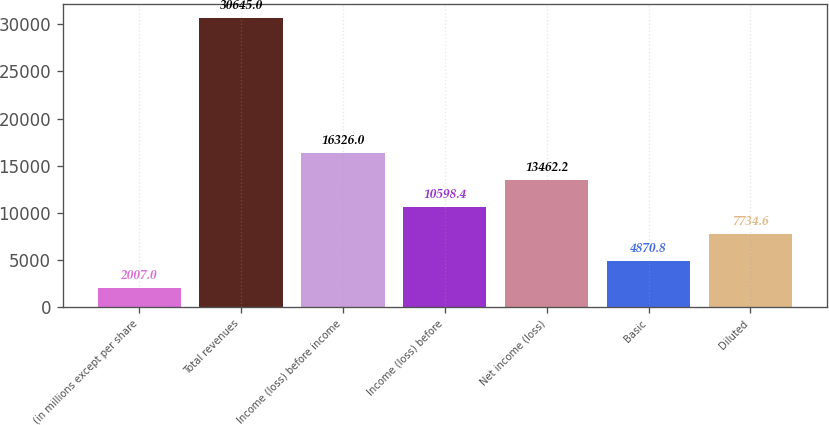Convert chart to OTSL. <chart><loc_0><loc_0><loc_500><loc_500><bar_chart><fcel>(in millions except per share<fcel>Total revenues<fcel>Income (loss) before income<fcel>Income (loss) before<fcel>Net income (loss)<fcel>Basic<fcel>Diluted<nl><fcel>2007<fcel>30645<fcel>16326<fcel>10598.4<fcel>13462.2<fcel>4870.8<fcel>7734.6<nl></chart> 